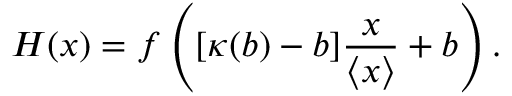Convert formula to latex. <formula><loc_0><loc_0><loc_500><loc_500>H ( x ) = f \left ( [ \kappa ( b ) - b ] \frac { x } { \left \langle { x } \right \rangle } + b \right ) .</formula> 